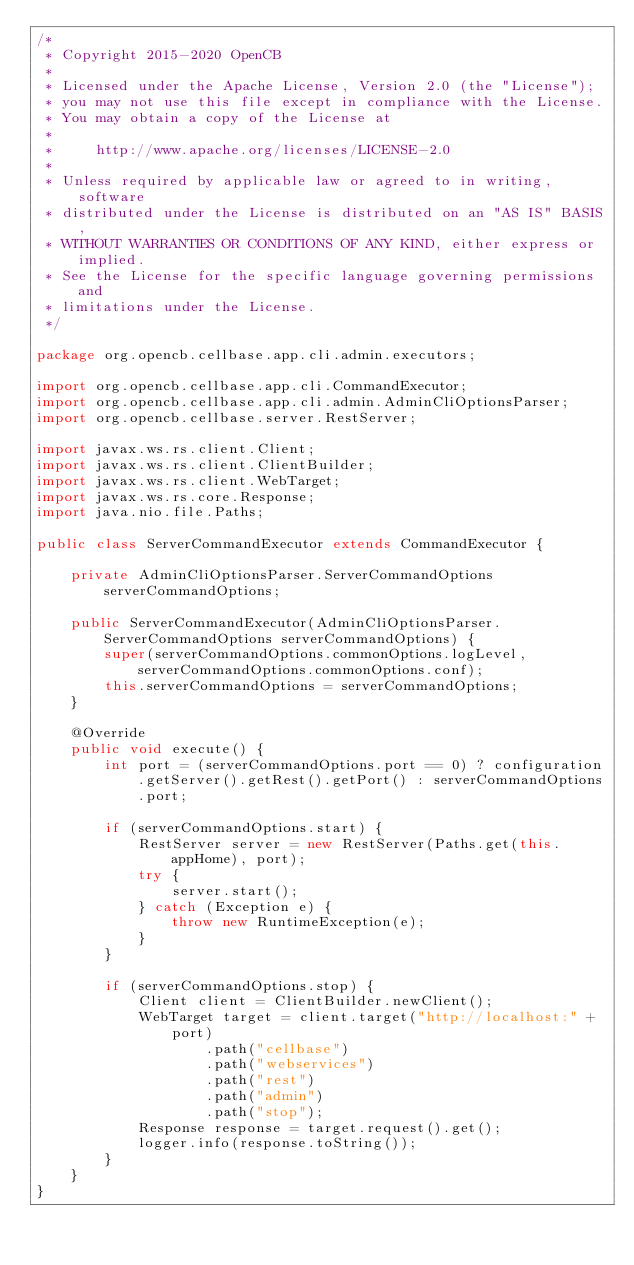<code> <loc_0><loc_0><loc_500><loc_500><_Java_>/*
 * Copyright 2015-2020 OpenCB
 *
 * Licensed under the Apache License, Version 2.0 (the "License");
 * you may not use this file except in compliance with the License.
 * You may obtain a copy of the License at
 *
 *     http://www.apache.org/licenses/LICENSE-2.0
 *
 * Unless required by applicable law or agreed to in writing, software
 * distributed under the License is distributed on an "AS IS" BASIS,
 * WITHOUT WARRANTIES OR CONDITIONS OF ANY KIND, either express or implied.
 * See the License for the specific language governing permissions and
 * limitations under the License.
 */

package org.opencb.cellbase.app.cli.admin.executors;

import org.opencb.cellbase.app.cli.CommandExecutor;
import org.opencb.cellbase.app.cli.admin.AdminCliOptionsParser;
import org.opencb.cellbase.server.RestServer;

import javax.ws.rs.client.Client;
import javax.ws.rs.client.ClientBuilder;
import javax.ws.rs.client.WebTarget;
import javax.ws.rs.core.Response;
import java.nio.file.Paths;

public class ServerCommandExecutor extends CommandExecutor {

    private AdminCliOptionsParser.ServerCommandOptions serverCommandOptions;

    public ServerCommandExecutor(AdminCliOptionsParser.ServerCommandOptions serverCommandOptions) {
        super(serverCommandOptions.commonOptions.logLevel, serverCommandOptions.commonOptions.conf);
        this.serverCommandOptions = serverCommandOptions;
    }

    @Override
    public void execute() {
        int port = (serverCommandOptions.port == 0) ? configuration.getServer().getRest().getPort() : serverCommandOptions.port;

        if (serverCommandOptions.start) {
            RestServer server = new RestServer(Paths.get(this.appHome), port);
            try {
                server.start();
            } catch (Exception e) {
                throw new RuntimeException(e);
            }
        }

        if (serverCommandOptions.stop) {
            Client client = ClientBuilder.newClient();
            WebTarget target = client.target("http://localhost:" + port)
                    .path("cellbase")
                    .path("webservices")
                    .path("rest")
                    .path("admin")
                    .path("stop");
            Response response = target.request().get();
            logger.info(response.toString());
        }
    }
}
</code> 